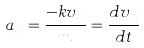Convert formula to latex. <formula><loc_0><loc_0><loc_500><loc_500>a _ { x } = \frac { - k v _ { x } } { m } = \frac { d v _ { x } } { d t }</formula> 